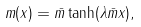<formula> <loc_0><loc_0><loc_500><loc_500>m ( x ) = \bar { m } \tanh ( \lambda \bar { m } x ) ,</formula> 